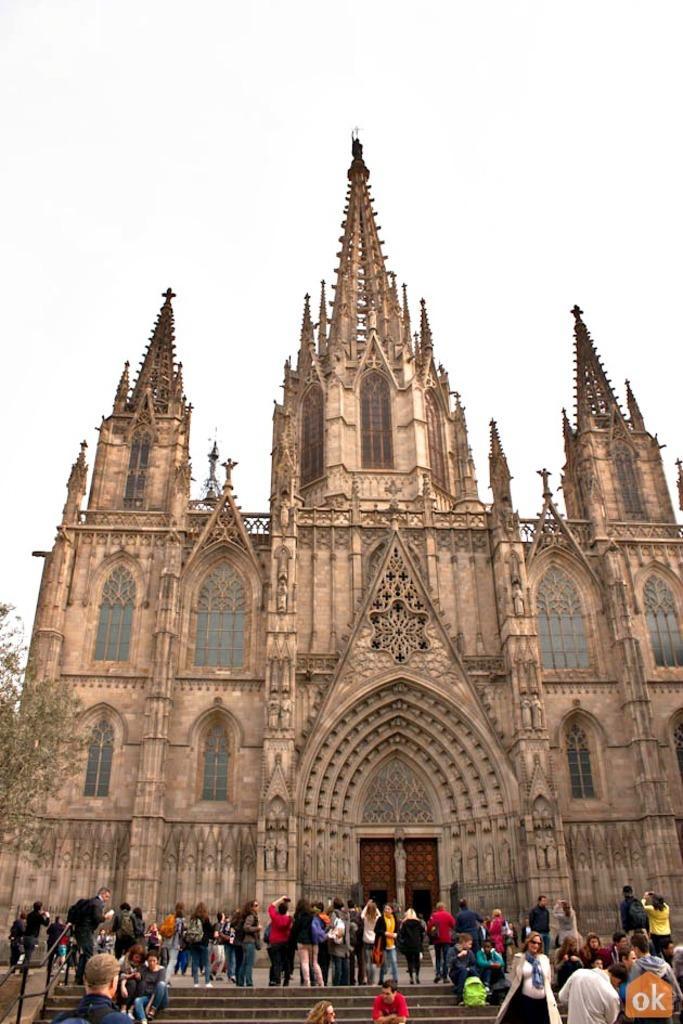Describe this image in one or two sentences. In this image I can see at the bottom a group of people are there, in the middle it is a very big building, on the left side there is a tree, at the top it is the sky. 